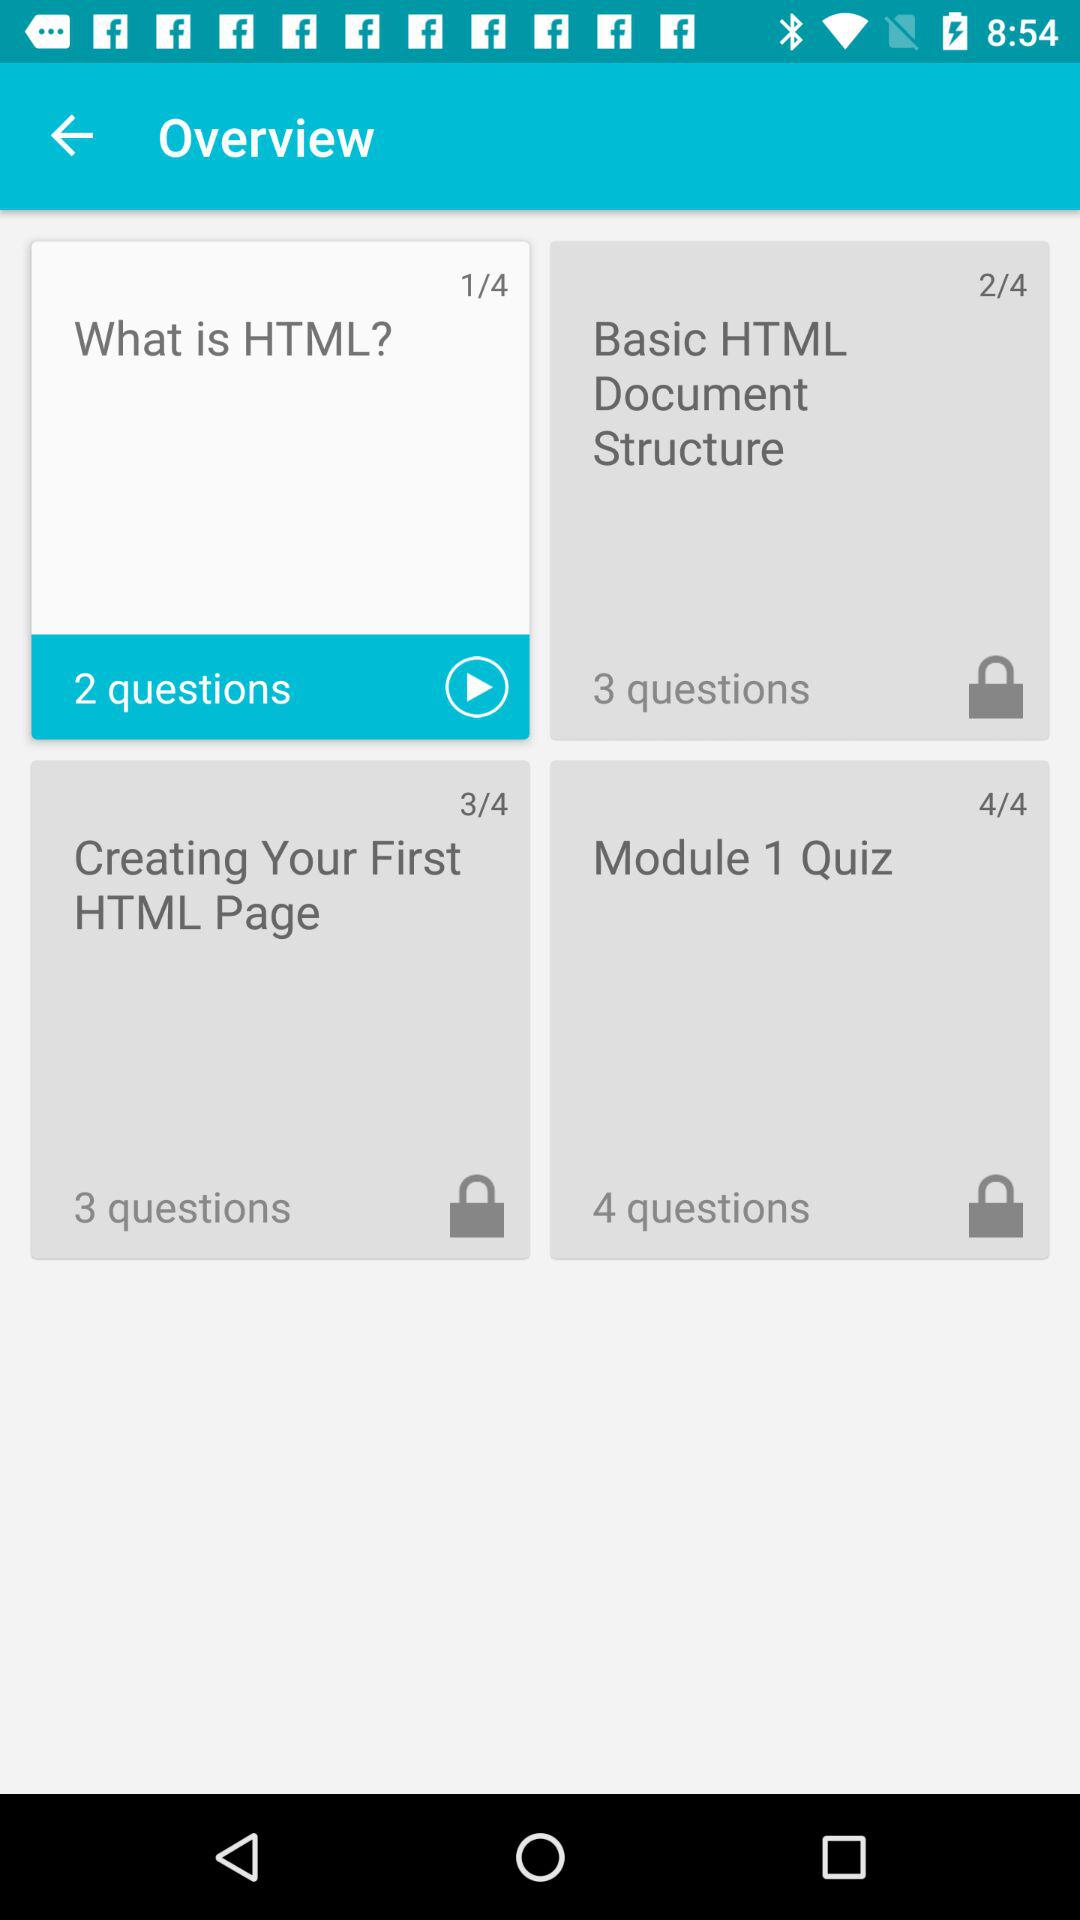What is the total count of the "Module 1 Quiz"? There are 4 questions in "Module 1 Quiz". 